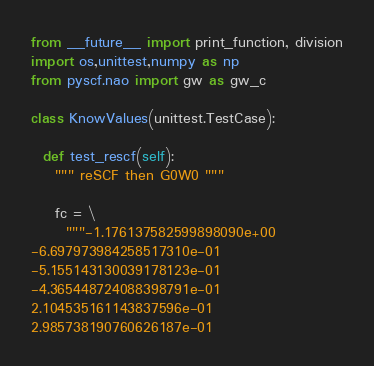<code> <loc_0><loc_0><loc_500><loc_500><_Python_>from __future__ import print_function, division
import os,unittest,numpy as np
from pyscf.nao import gw as gw_c

class KnowValues(unittest.TestCase):

  def test_rescf(self):
    """ reSCF then G0W0 """
    
    fc = \
      """-1.176137582599898090e+00
-6.697973984258517310e-01
-5.155143130039178123e-01
-4.365448724088398791e-01
2.104535161143837596e-01
2.985738190760626187e-01</code> 